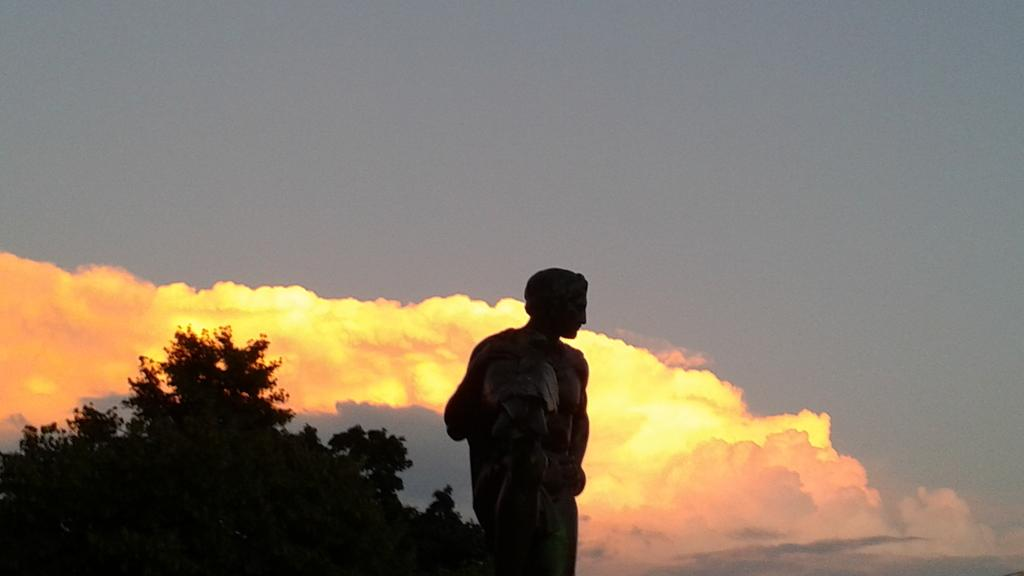What is the main subject of the image? There is a person standing in the image. What type of natural environment is visible in the image? There are trees visible in the image. How would you describe the weather in the image? The sky is cloudy in the image. What type of wine is being served in the image? There is no wine present in the image; it features a person standing in a natural environment with trees and a cloudy sky. 